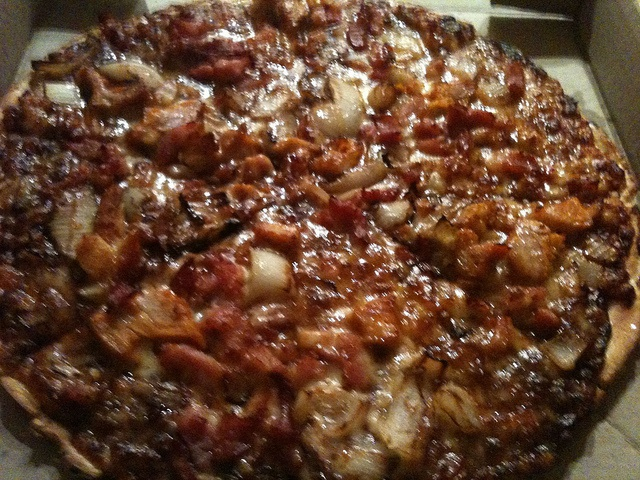Describe the objects in this image and their specific colors. I can see a pizza in maroon, black, and gray tones in this image. 